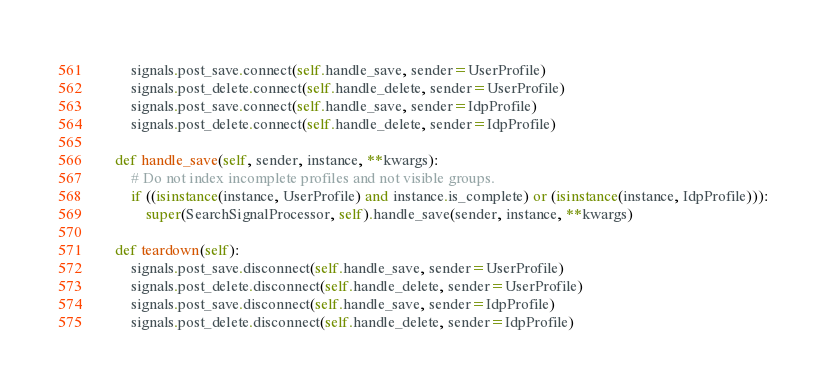Convert code to text. <code><loc_0><loc_0><loc_500><loc_500><_Python_>        signals.post_save.connect(self.handle_save, sender=UserProfile)
        signals.post_delete.connect(self.handle_delete, sender=UserProfile)
        signals.post_save.connect(self.handle_save, sender=IdpProfile)
        signals.post_delete.connect(self.handle_delete, sender=IdpProfile)

    def handle_save(self, sender, instance, **kwargs):
        # Do not index incomplete profiles and not visible groups.
        if ((isinstance(instance, UserProfile) and instance.is_complete) or (isinstance(instance, IdpProfile))):
            super(SearchSignalProcessor, self).handle_save(sender, instance, **kwargs)

    def teardown(self):
        signals.post_save.disconnect(self.handle_save, sender=UserProfile)
        signals.post_delete.disconnect(self.handle_delete, sender=UserProfile)
        signals.post_save.disconnect(self.handle_save, sender=IdpProfile)
        signals.post_delete.disconnect(self.handle_delete, sender=IdpProfile)
</code> 